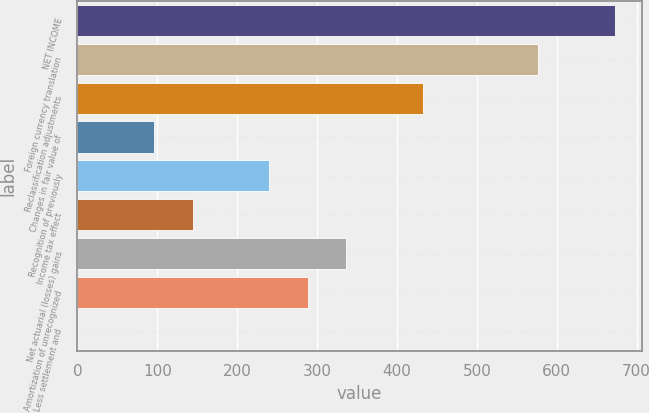Convert chart. <chart><loc_0><loc_0><loc_500><loc_500><bar_chart><fcel>NET INCOME<fcel>Foreign currency translation<fcel>Reclassification adjustments<fcel>Changes in fair value of<fcel>Recognition of previously<fcel>Income tax effect<fcel>Net actuarial (losses) gains<fcel>Amortization of unrecognized<fcel>Less settlement and<nl><fcel>672.62<fcel>576.56<fcel>432.47<fcel>96.26<fcel>240.35<fcel>144.29<fcel>336.41<fcel>288.38<fcel>0.2<nl></chart> 